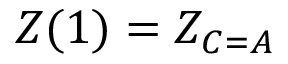<formula> <loc_0><loc_0><loc_500><loc_500>Z ( 1 ) = Z _ { C = A }</formula> 